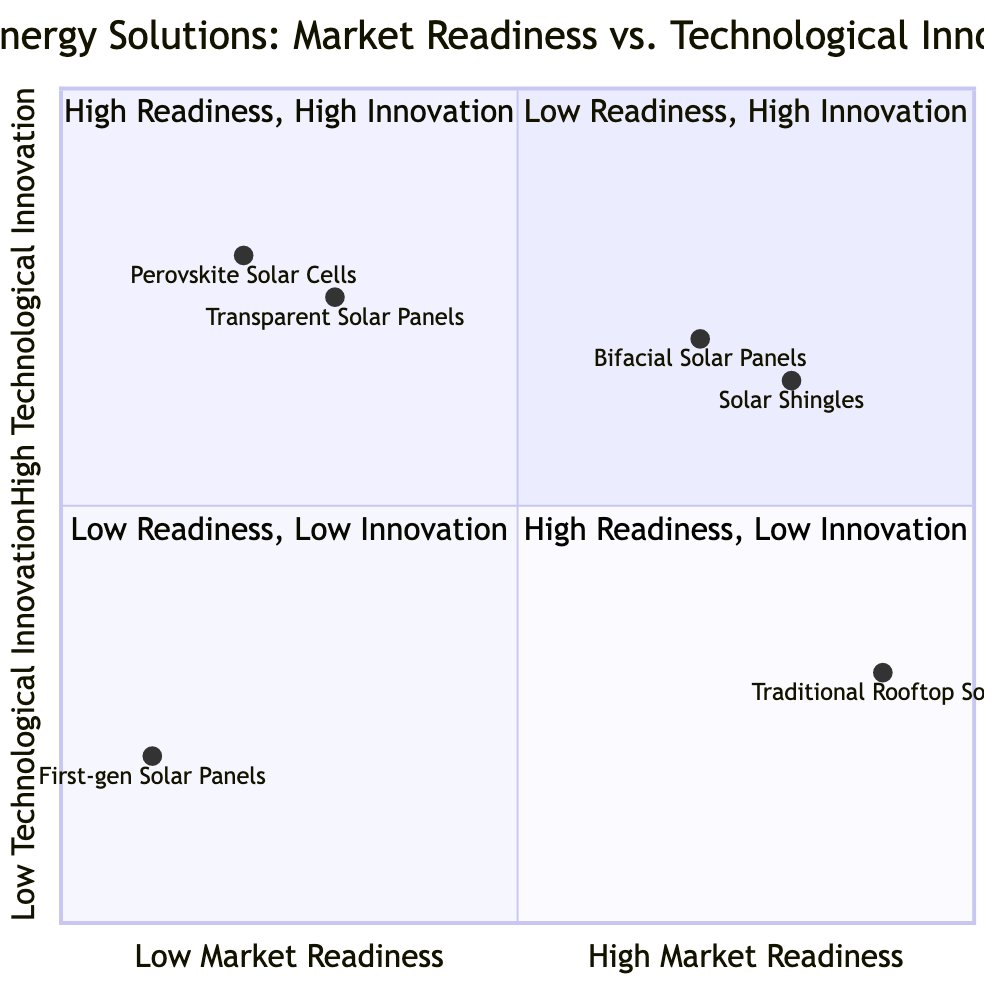What is the example product in the bottom-left quadrant? The bottom-left quadrant is labeled "Low Readiness, Low Innovation". The example product listed here is "First-gen Solar Panels," indicating it has older technology that lacks market attraction and has basic efficiency.
Answer: First-gen Solar Panels How many products are in the top-right quadrant? In the top-right quadrant, labeled "High Readiness, High Innovation," there are two example products listed: "Bifacial Solar Panels" and "Solar Shingles." Therefore, the total is counted as two.
Answer: 2 Which product has the highest market readiness? The product with the highest market readiness is "Traditional Rooftop Solar," which is located at the right-most end of the x-axis, indicating it has a market readiness value of 0.9.
Answer: Traditional Rooftop Solar What is the technological innovation value of Perovskite Solar Cells? The value for Perovskite Solar Cells on the y-axis, indicating technological innovation, is represented as 0.8. This means it is positioned high on the technological innovation scale.
Answer: 0.8 Which quadrant contains products that are highly innovative with good consumer adoption potential? The quadrant that features products that are highly innovative and have potential for consumer adoption is the top-right quadrant labeled "High Readiness, High Innovation," which includes "Bifacial Solar Panels" and "Solar Shingles."
Answer: High Readiness, High Innovation What is the market readiness value of the Transparent Solar Panels? The market readiness value of Transparent Solar Panels is recorded as 0.3 on the x-axis, indicating a moderate level of market readiness, but lower than some other products.
Answer: 0.3 Which product is listed in the top-left quadrant? The top-left quadrant is labeled "Low Readiness, High Innovation." The example products in this quadrant are "Perovskite Solar Cells" and "Transparent Solar Panels," indicating advanced innovations that are less ready for market.
Answer: Perovskite Solar Cells, Transparent Solar Panels What is the positioning of Solar Shingles in terms of market readiness and technological innovation? Solar Shingles are positioned in the top-right quadrant at coordinates [0.8, 0.65], which indicates a high market readiness value of 0.8 and a good technological innovation score of 0.65. This suggests it is well-adapted for consumer adoption while being innovative.
Answer: [0.8, 0.65] 